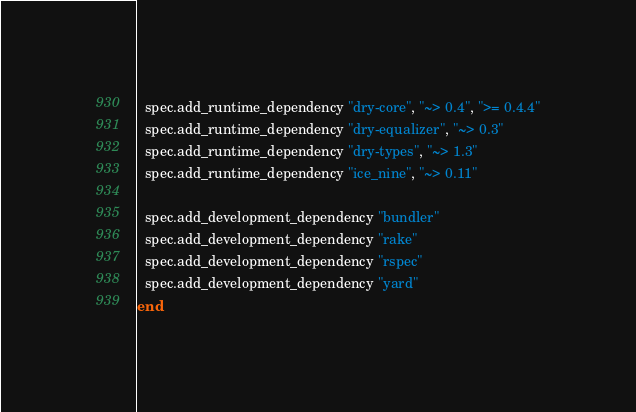Convert code to text. <code><loc_0><loc_0><loc_500><loc_500><_Ruby_>  spec.add_runtime_dependency "dry-core", "~> 0.4", ">= 0.4.4"
  spec.add_runtime_dependency "dry-equalizer", "~> 0.3"
  spec.add_runtime_dependency "dry-types", "~> 1.3"
  spec.add_runtime_dependency "ice_nine", "~> 0.11"

  spec.add_development_dependency "bundler"
  spec.add_development_dependency "rake"
  spec.add_development_dependency "rspec"
  spec.add_development_dependency "yard"
end
</code> 